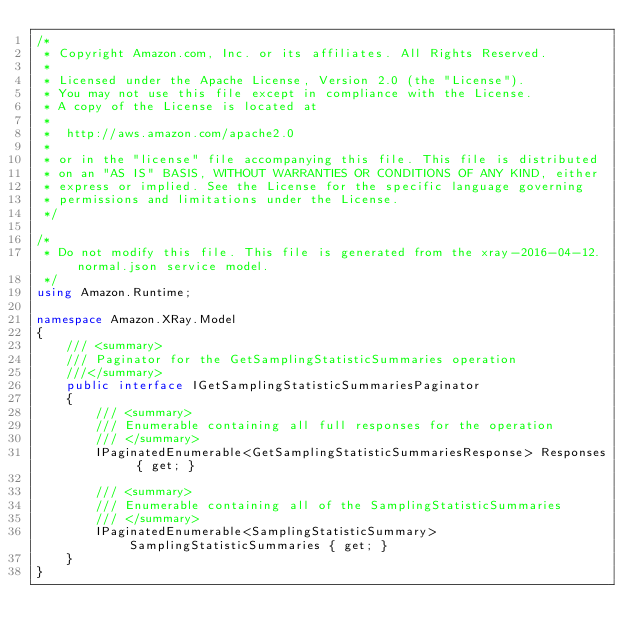<code> <loc_0><loc_0><loc_500><loc_500><_C#_>/*
 * Copyright Amazon.com, Inc. or its affiliates. All Rights Reserved.
 * 
 * Licensed under the Apache License, Version 2.0 (the "License").
 * You may not use this file except in compliance with the License.
 * A copy of the License is located at
 * 
 *  http://aws.amazon.com/apache2.0
 * 
 * or in the "license" file accompanying this file. This file is distributed
 * on an "AS IS" BASIS, WITHOUT WARRANTIES OR CONDITIONS OF ANY KIND, either
 * express or implied. See the License for the specific language governing
 * permissions and limitations under the License.
 */

/*
 * Do not modify this file. This file is generated from the xray-2016-04-12.normal.json service model.
 */
using Amazon.Runtime;

namespace Amazon.XRay.Model
{
    /// <summary>
    /// Paginator for the GetSamplingStatisticSummaries operation
    ///</summary>
    public interface IGetSamplingStatisticSummariesPaginator
    {
        /// <summary>
        /// Enumerable containing all full responses for the operation
        /// </summary>
        IPaginatedEnumerable<GetSamplingStatisticSummariesResponse> Responses { get; }

        /// <summary>
        /// Enumerable containing all of the SamplingStatisticSummaries
        /// </summary>
        IPaginatedEnumerable<SamplingStatisticSummary> SamplingStatisticSummaries { get; }
    }
}</code> 